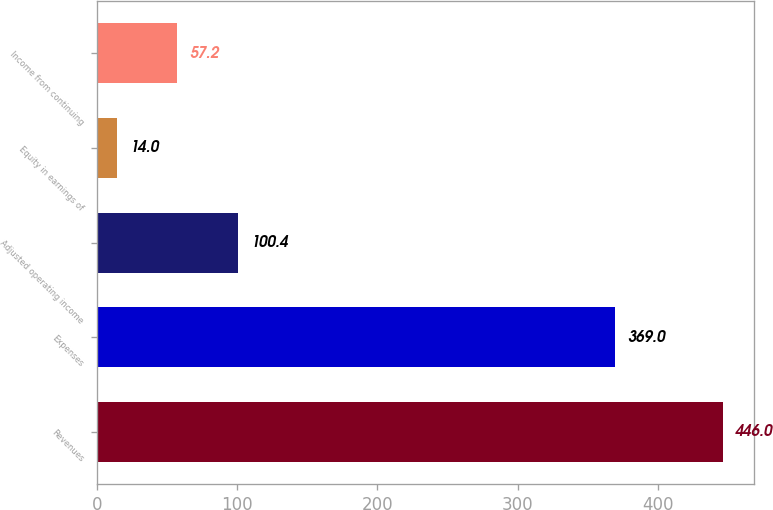<chart> <loc_0><loc_0><loc_500><loc_500><bar_chart><fcel>Revenues<fcel>Expenses<fcel>Adjusted operating income<fcel>Equity in earnings of<fcel>Income from continuing<nl><fcel>446<fcel>369<fcel>100.4<fcel>14<fcel>57.2<nl></chart> 